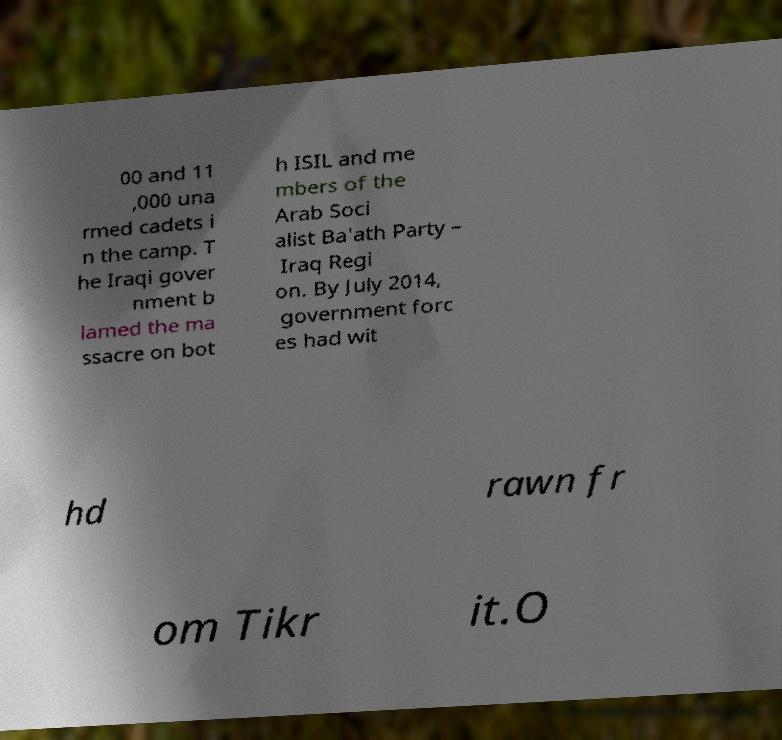Can you read and provide the text displayed in the image?This photo seems to have some interesting text. Can you extract and type it out for me? 00 and 11 ,000 una rmed cadets i n the camp. T he Iraqi gover nment b lamed the ma ssacre on bot h ISIL and me mbers of the Arab Soci alist Ba'ath Party – Iraq Regi on. By July 2014, government forc es had wit hd rawn fr om Tikr it.O 